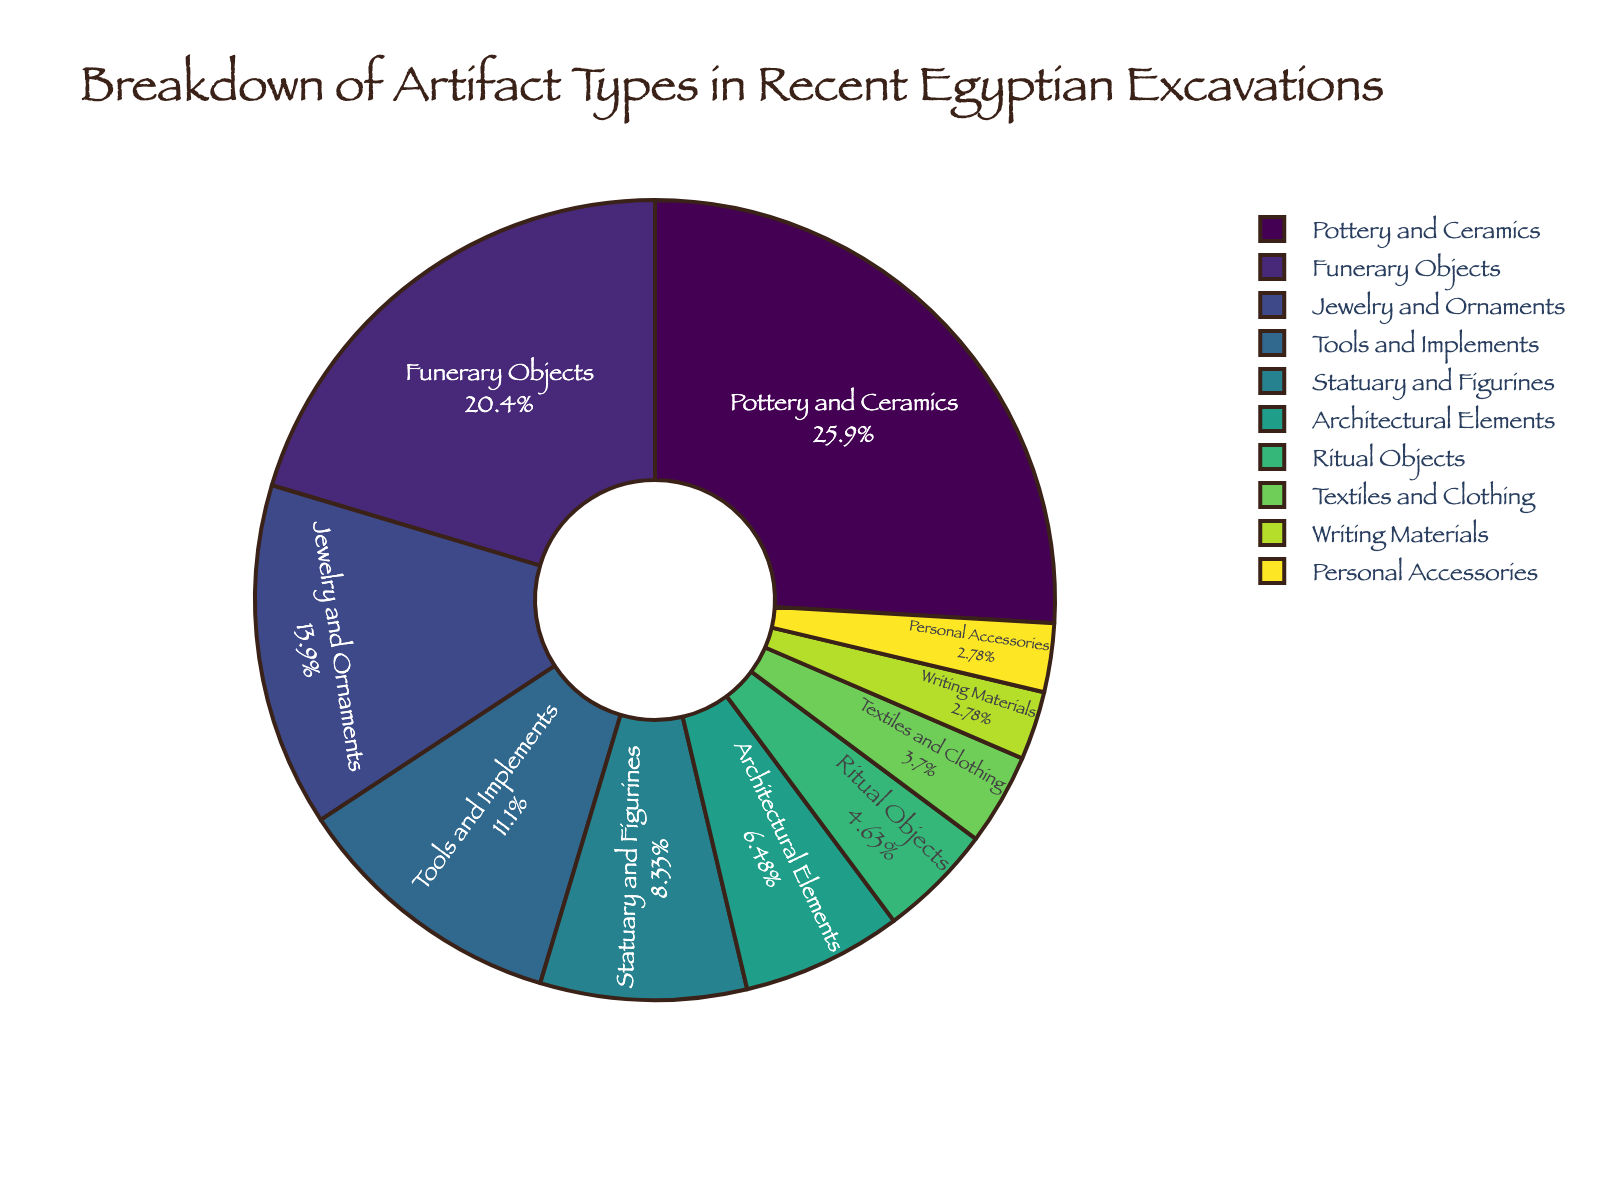What percentage of artifacts discovered are Jewelry and Ornaments? The chart shows a section indicating the percentage of Jewelry and Ornaments. By looking at this section, we see it's labeled "Jewelry and Ornaments" with 15%.
Answer: 15% Which type of artifact is discovered the most frequently? Pottery and Ceramics have the largest section in the pie chart, indicating it has the highest percentage compared to other categories.
Answer: Pottery and Ceramics What is the combined percentage of Funerary Objects and Tools and Implements? Funerary Objects are 22% and Tools and Implements are 12%. Adding these two percentages together gives 22% + 12% = 34%.
Answer: 34% Which category has a lower percentage: Ritual Objects or Personal Accessories? Ritual Objects have a segment labeled 5%, and Personal Accessories have a segment labeled 3%. Since 3% is less than 5%, Personal Accessories have a lower percentage.
Answer: Personal Accessories What is the difference in percentage between Statuary and Figurines and Architectural Elements? Statuary and Figurines account for 9% and Architectural Elements for 7%. The difference is calculated as 9% - 7% = 2%.
Answer: 2% What is the total percentage of Textiles and Clothing and Writing Materials combined? Textiles and Clothing are 4% and Writing Materials are 3%. Adding these two gives 4% + 3% = 7%.
Answer: 7% Which two categories combined give a percentage closest to Tools and Implements? The percentage for Tools and Implements is 12%. Personal Accessories (3%) and Writing Materials (3%) together sum up to 3% + 3% = 6%, and then adding Ritual Objects (5%) gives 6% + 5% = 11%, which is closest to 12%.
Answer: Personal Accessories and Ritual Objects Is the percentage of Pottery and Ceramics more than twice the percentage of Funerary Objects? Pottery and Ceramics are 28% and Funerary Objects are 22%. Twice the percentage of Funerary Objects is 2*22% = 44%. Since 28% is less than 44%, the percentage of Pottery and Ceramics is not more than twice the percentage of Funerary Objects.
Answer: No How much more is the percentage of Jewelry and Ornaments compared to Writing Materials? Jewelry and Ornaments are 15%, and Writing Materials are 3%. The difference is calculated as 15% - 3% = 12%.
Answer: 12% Which category would need to increase by 4% to equal the percentage of Funerary Objects? Funerary Objects are 22%. Categories like Tools and Implements are currently at 12%. Adding 4% to Tools and Implements' percentage gives 12% + 4% = 16%, which would still not reach 22%, leaving Personal Accessories or Writing Materials needing to add more than 4% each. Therefore, Ritual Objects at 5% adding 4% makes it only 9%. None fit this exactly with just a 4% increase needed.
Answer: None 